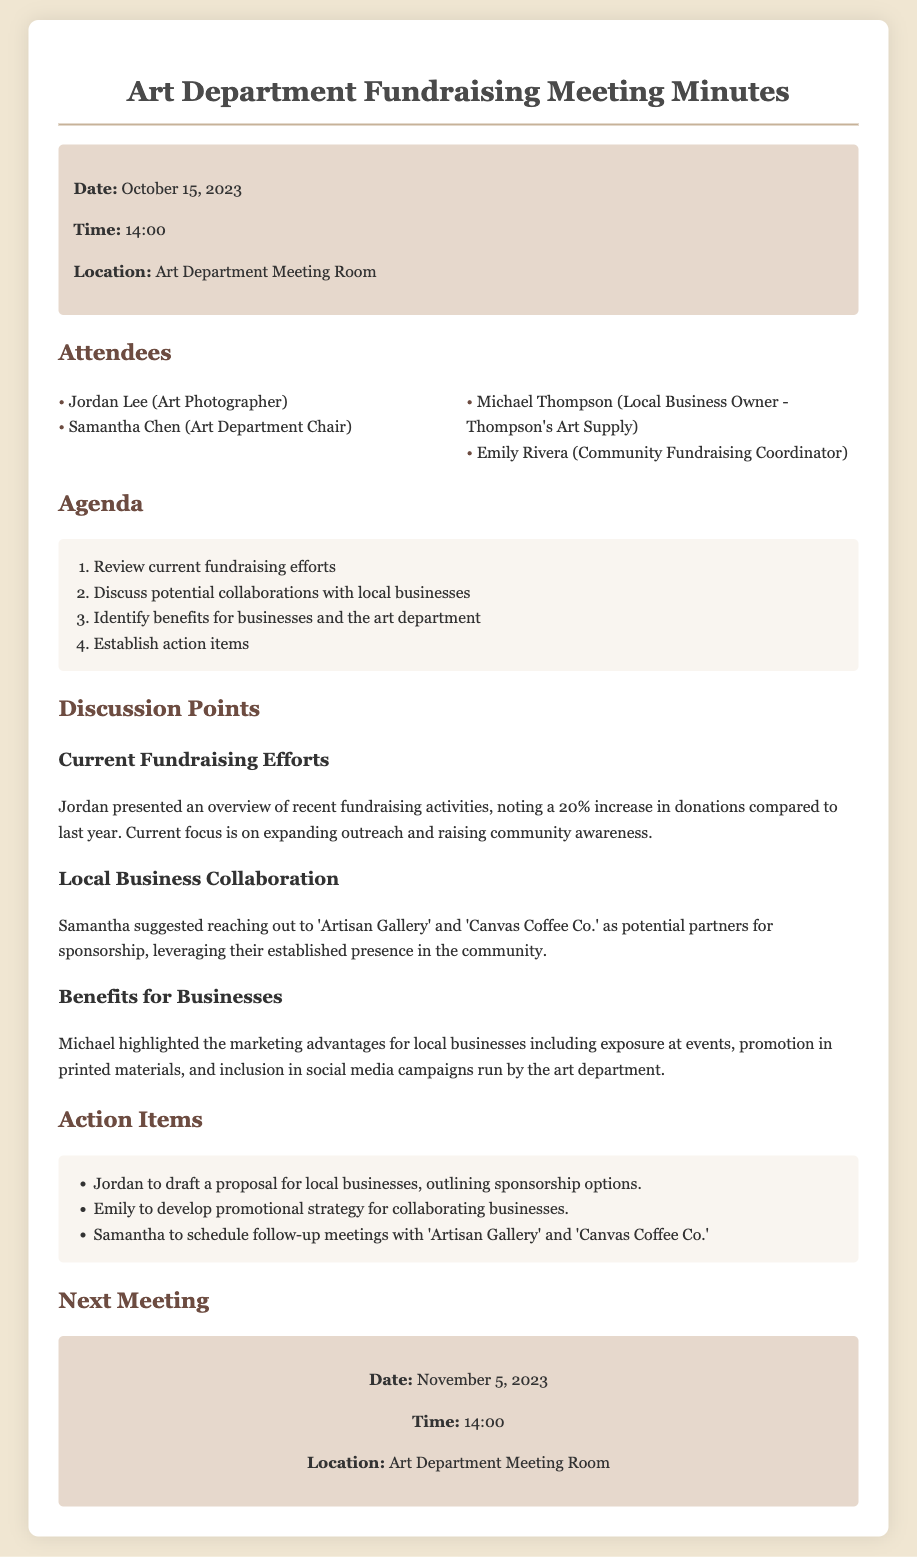what date was the meeting held? The date of the meeting is stated in the meeting info section.
Answer: October 15, 2023 who presented the overview of recent fundraising activities? Jordan Lee is mentioned as the person who provided the overview.
Answer: Jordan which businesses were suggested for collaboration? The document lists 'Artisan Gallery' and 'Canvas Coffee Co.' as suggested partners.
Answer: Artisan Gallery and Canvas Coffee Co what is the percentage increase in donations compared to last year? The document specifies a 20% increase in donations mentioned by Jordan.
Answer: 20% who is responsible for drafting the proposal for local businesses? The action items section indicates that Jordan is tasked with drafting the proposal.
Answer: Jordan what is the main focus of the current fundraising efforts? The document states that the current focus is on expanding outreach and raising community awareness.
Answer: Expanding outreach and raising community awareness when is the next scheduled meeting? The next meeting date is outlined in the next meeting section.
Answer: November 5, 2023 what marketing advantages did Michael highlight for local businesses? The document notes several marketing advantages including exposure at events and promotion in materials.
Answer: Exposure at events, promotion in materials who will develop the promotional strategy for collaborating businesses? Emily is assigned to develop the promotional strategy according to the action items.
Answer: Emily 